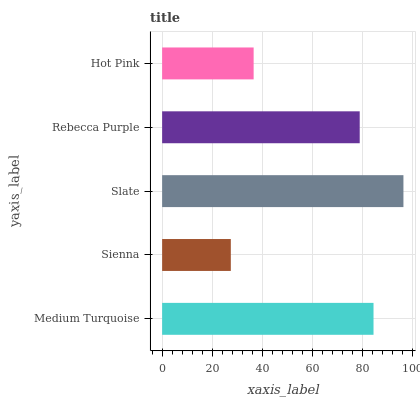Is Sienna the minimum?
Answer yes or no. Yes. Is Slate the maximum?
Answer yes or no. Yes. Is Slate the minimum?
Answer yes or no. No. Is Sienna the maximum?
Answer yes or no. No. Is Slate greater than Sienna?
Answer yes or no. Yes. Is Sienna less than Slate?
Answer yes or no. Yes. Is Sienna greater than Slate?
Answer yes or no. No. Is Slate less than Sienna?
Answer yes or no. No. Is Rebecca Purple the high median?
Answer yes or no. Yes. Is Rebecca Purple the low median?
Answer yes or no. Yes. Is Sienna the high median?
Answer yes or no. No. Is Slate the low median?
Answer yes or no. No. 